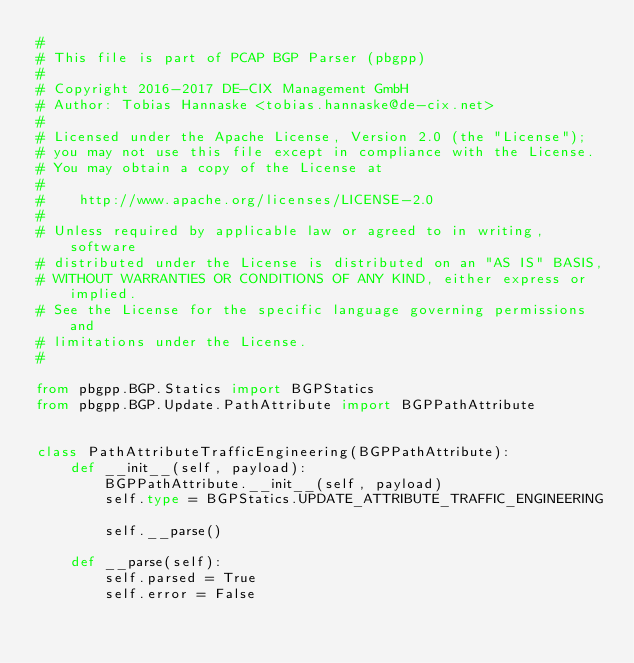<code> <loc_0><loc_0><loc_500><loc_500><_Python_>#
# This file is part of PCAP BGP Parser (pbgpp)
#
# Copyright 2016-2017 DE-CIX Management GmbH
# Author: Tobias Hannaske <tobias.hannaske@de-cix.net>
#
# Licensed under the Apache License, Version 2.0 (the "License");
# you may not use this file except in compliance with the License.
# You may obtain a copy of the License at
#
#    http://www.apache.org/licenses/LICENSE-2.0
#
# Unless required by applicable law or agreed to in writing, software
# distributed under the License is distributed on an "AS IS" BASIS,
# WITHOUT WARRANTIES OR CONDITIONS OF ANY KIND, either express or implied.
# See the License for the specific language governing permissions and
# limitations under the License.
#

from pbgpp.BGP.Statics import BGPStatics
from pbgpp.BGP.Update.PathAttribute import BGPPathAttribute


class PathAttributeTrafficEngineering(BGPPathAttribute):
    def __init__(self, payload):
        BGPPathAttribute.__init__(self, payload)
        self.type = BGPStatics.UPDATE_ATTRIBUTE_TRAFFIC_ENGINEERING

        self.__parse()

    def __parse(self):
        self.parsed = True
        self.error = False
</code> 